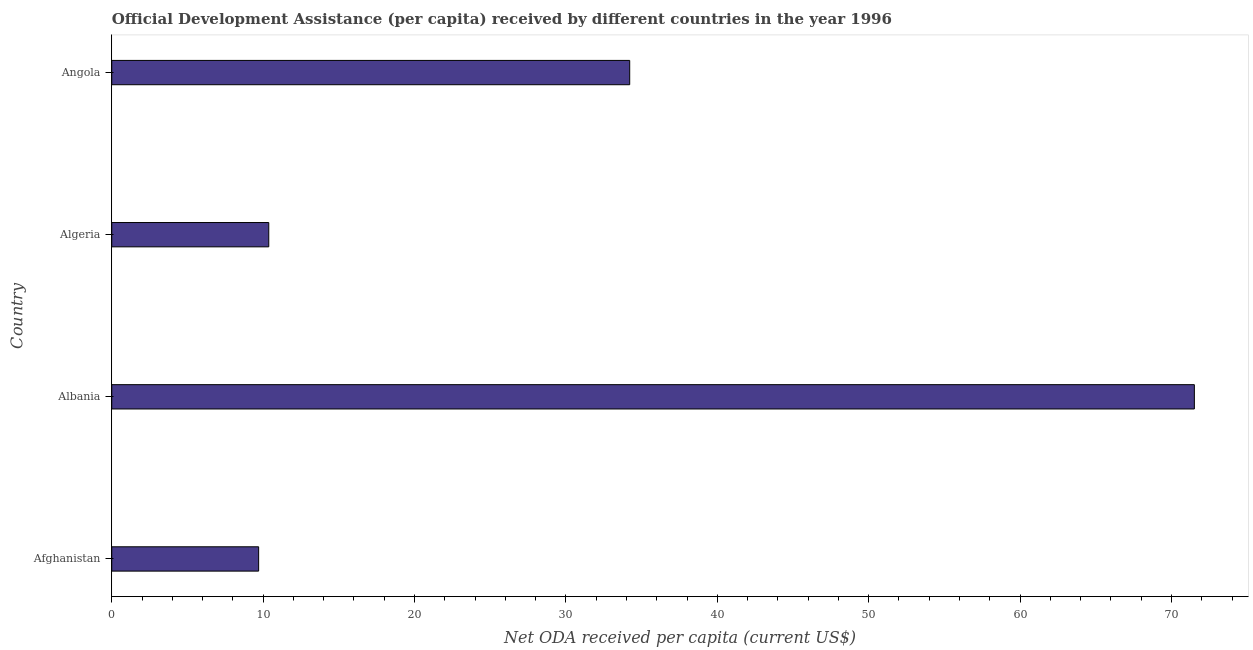Does the graph contain any zero values?
Offer a terse response. No. What is the title of the graph?
Keep it short and to the point. Official Development Assistance (per capita) received by different countries in the year 1996. What is the label or title of the X-axis?
Your answer should be very brief. Net ODA received per capita (current US$). What is the net oda received per capita in Angola?
Ensure brevity in your answer.  34.21. Across all countries, what is the maximum net oda received per capita?
Provide a succinct answer. 71.51. Across all countries, what is the minimum net oda received per capita?
Make the answer very short. 9.7. In which country was the net oda received per capita maximum?
Your answer should be very brief. Albania. In which country was the net oda received per capita minimum?
Your answer should be very brief. Afghanistan. What is the sum of the net oda received per capita?
Your answer should be very brief. 125.8. What is the difference between the net oda received per capita in Afghanistan and Algeria?
Offer a terse response. -0.67. What is the average net oda received per capita per country?
Make the answer very short. 31.45. What is the median net oda received per capita?
Provide a succinct answer. 22.29. What is the ratio of the net oda received per capita in Algeria to that in Angola?
Provide a succinct answer. 0.3. Is the difference between the net oda received per capita in Afghanistan and Algeria greater than the difference between any two countries?
Offer a terse response. No. What is the difference between the highest and the second highest net oda received per capita?
Offer a very short reply. 37.3. What is the difference between the highest and the lowest net oda received per capita?
Make the answer very short. 61.81. In how many countries, is the net oda received per capita greater than the average net oda received per capita taken over all countries?
Ensure brevity in your answer.  2. How many countries are there in the graph?
Offer a terse response. 4. What is the Net ODA received per capita (current US$) in Afghanistan?
Give a very brief answer. 9.7. What is the Net ODA received per capita (current US$) of Albania?
Your answer should be very brief. 71.51. What is the Net ODA received per capita (current US$) in Algeria?
Offer a very short reply. 10.37. What is the Net ODA received per capita (current US$) in Angola?
Your response must be concise. 34.21. What is the difference between the Net ODA received per capita (current US$) in Afghanistan and Albania?
Provide a succinct answer. -61.81. What is the difference between the Net ODA received per capita (current US$) in Afghanistan and Algeria?
Provide a short and direct response. -0.67. What is the difference between the Net ODA received per capita (current US$) in Afghanistan and Angola?
Give a very brief answer. -24.51. What is the difference between the Net ODA received per capita (current US$) in Albania and Algeria?
Ensure brevity in your answer.  61.14. What is the difference between the Net ODA received per capita (current US$) in Albania and Angola?
Keep it short and to the point. 37.3. What is the difference between the Net ODA received per capita (current US$) in Algeria and Angola?
Your answer should be compact. -23.84. What is the ratio of the Net ODA received per capita (current US$) in Afghanistan to that in Albania?
Provide a succinct answer. 0.14. What is the ratio of the Net ODA received per capita (current US$) in Afghanistan to that in Algeria?
Offer a terse response. 0.94. What is the ratio of the Net ODA received per capita (current US$) in Afghanistan to that in Angola?
Your answer should be compact. 0.28. What is the ratio of the Net ODA received per capita (current US$) in Albania to that in Algeria?
Your answer should be very brief. 6.89. What is the ratio of the Net ODA received per capita (current US$) in Albania to that in Angola?
Make the answer very short. 2.09. What is the ratio of the Net ODA received per capita (current US$) in Algeria to that in Angola?
Offer a very short reply. 0.3. 